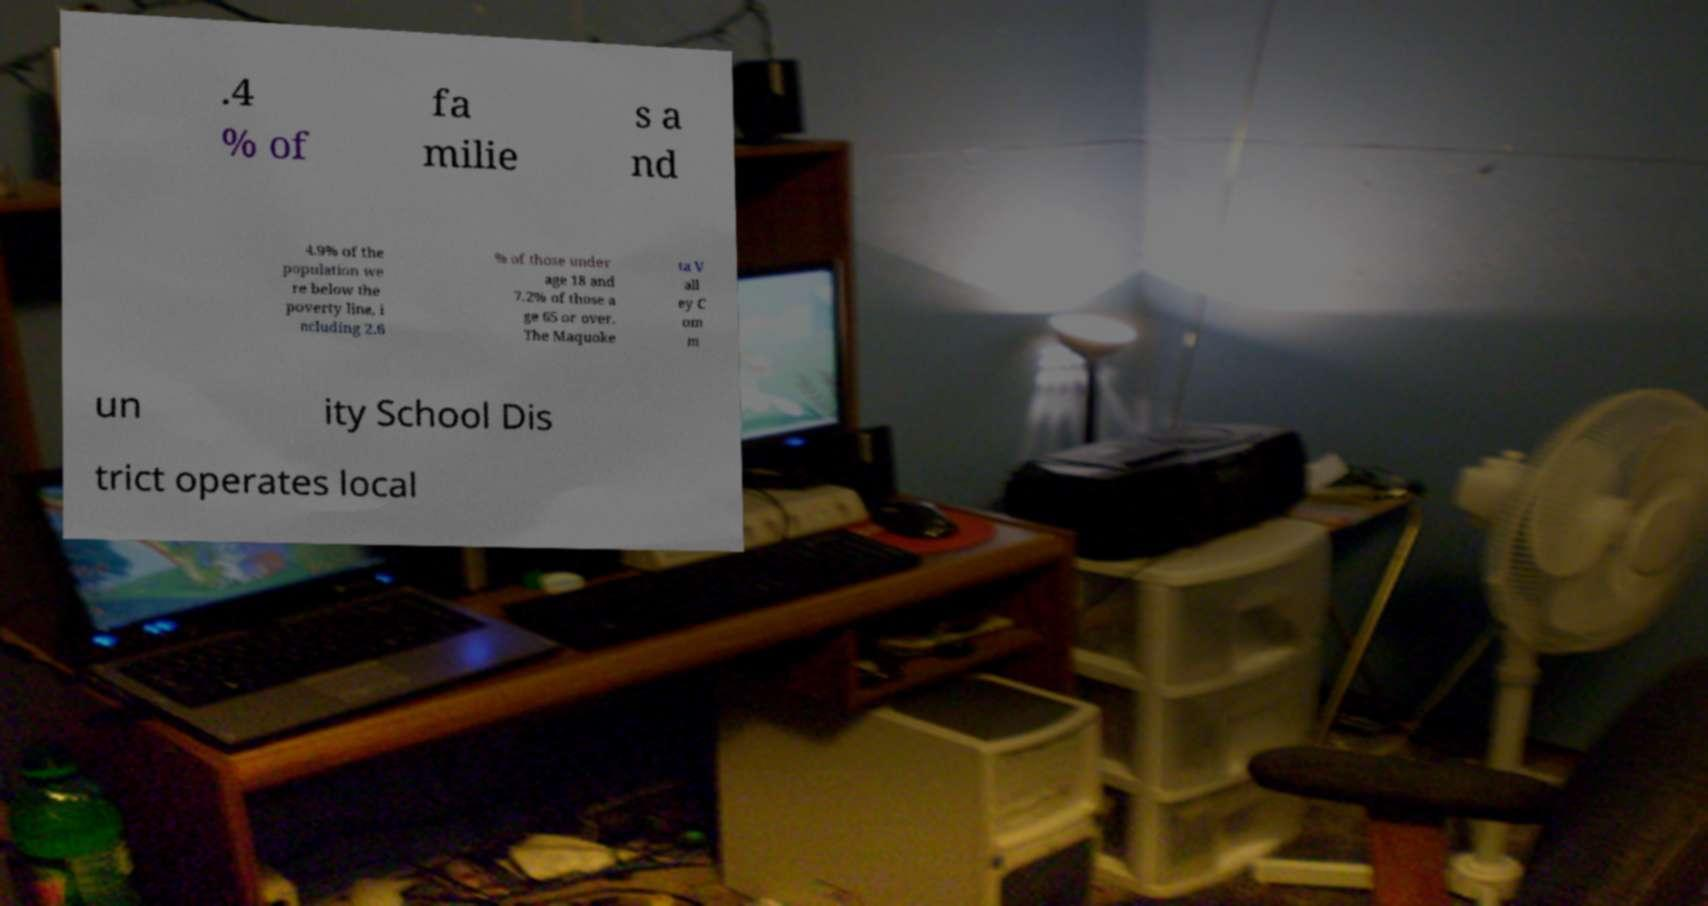Can you accurately transcribe the text from the provided image for me? .4 % of fa milie s a nd 4.9% of the population we re below the poverty line, i ncluding 2.6 % of those under age 18 and 7.2% of those a ge 65 or over. The Maquoke ta V all ey C om m un ity School Dis trict operates local 